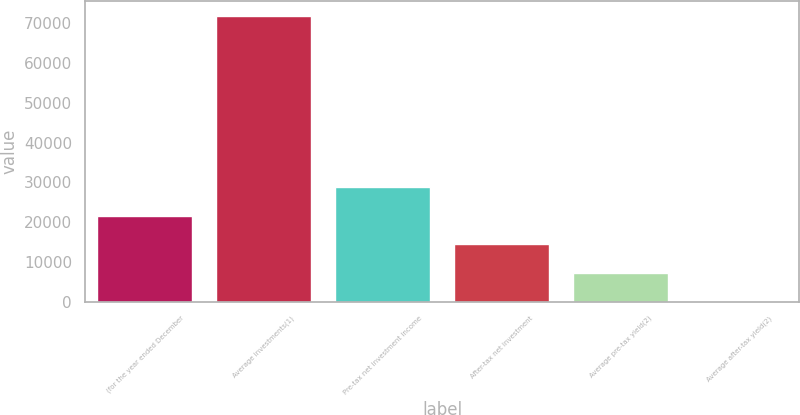Convert chart. <chart><loc_0><loc_0><loc_500><loc_500><bar_chart><fcel>(for the year ended December<fcel>Average investments(1)<fcel>Pre-tax net investment income<fcel>After-tax net investment<fcel>Average pre-tax yield(2)<fcel>Average after-tax yield(2)<nl><fcel>21561.9<fcel>71867<fcel>28748.4<fcel>14375.5<fcel>7189.04<fcel>2.6<nl></chart> 